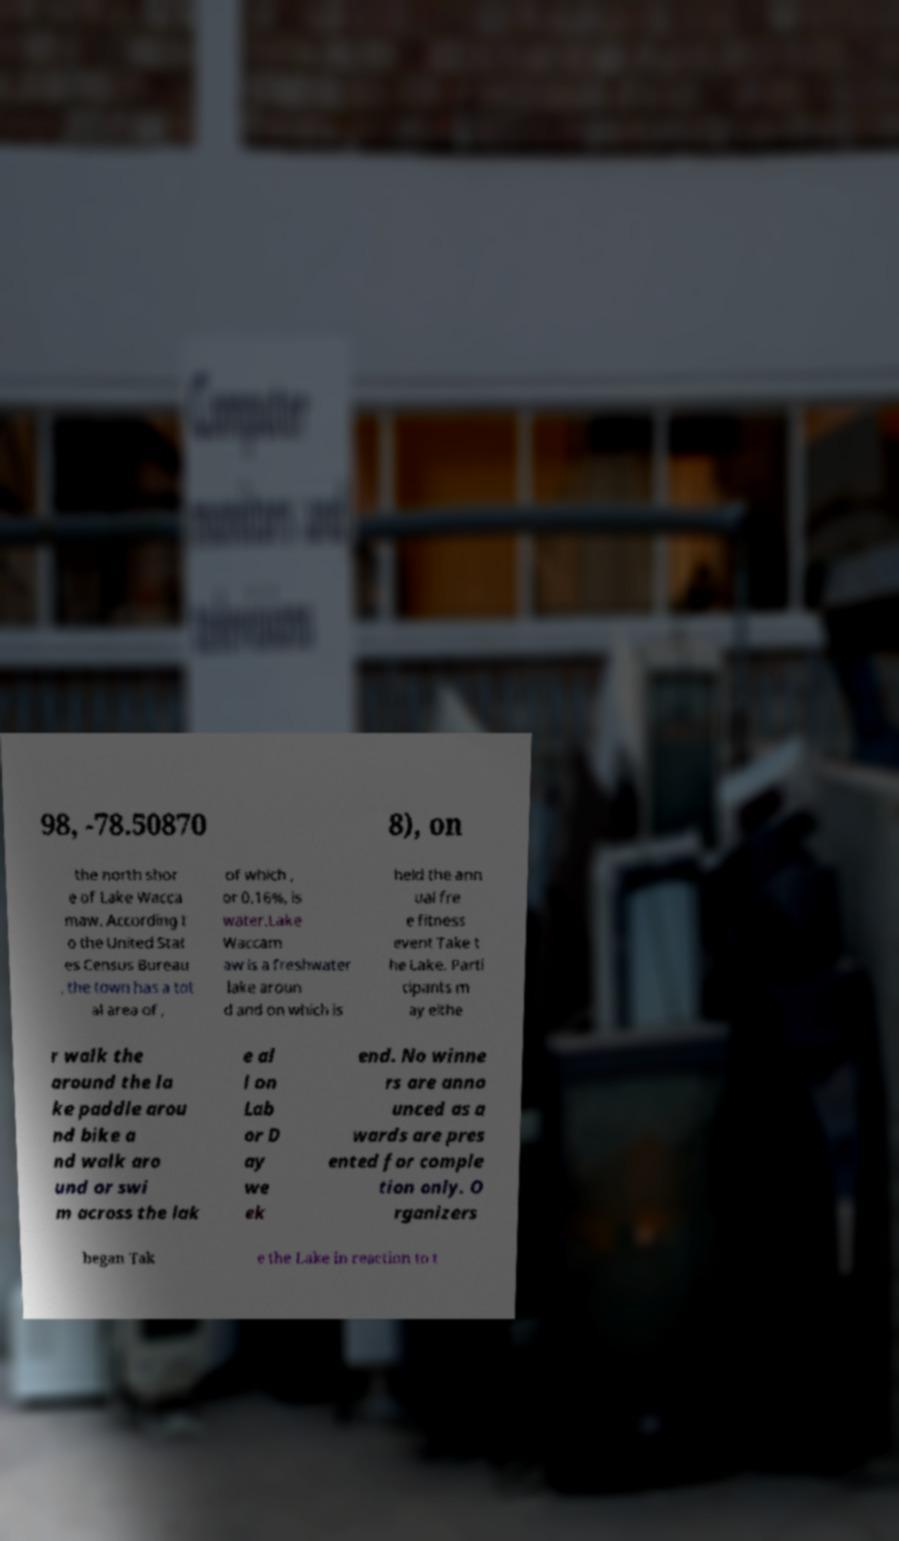Can you accurately transcribe the text from the provided image for me? 98, -78.50870 8), on the north shor e of Lake Wacca maw. According t o the United Stat es Census Bureau , the town has a tot al area of , of which , or 0.16%, is water.Lake Waccam aw is a freshwater lake aroun d and on which is held the ann ual fre e fitness event Take t he Lake. Parti cipants m ay eithe r walk the around the la ke paddle arou nd bike a nd walk aro und or swi m across the lak e al l on Lab or D ay we ek end. No winne rs are anno unced as a wards are pres ented for comple tion only. O rganizers began Tak e the Lake in reaction to t 